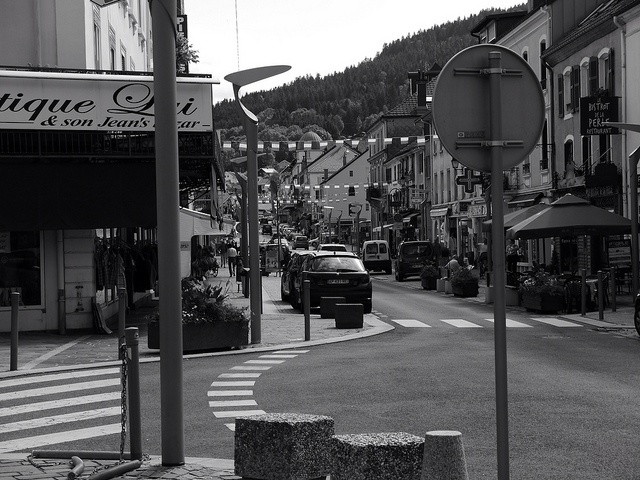Describe the objects in this image and their specific colors. I can see potted plant in gray and black tones, umbrella in gray and black tones, car in gray, black, darkgray, and lightgray tones, potted plant in gray and black tones, and truck in gray and black tones in this image. 